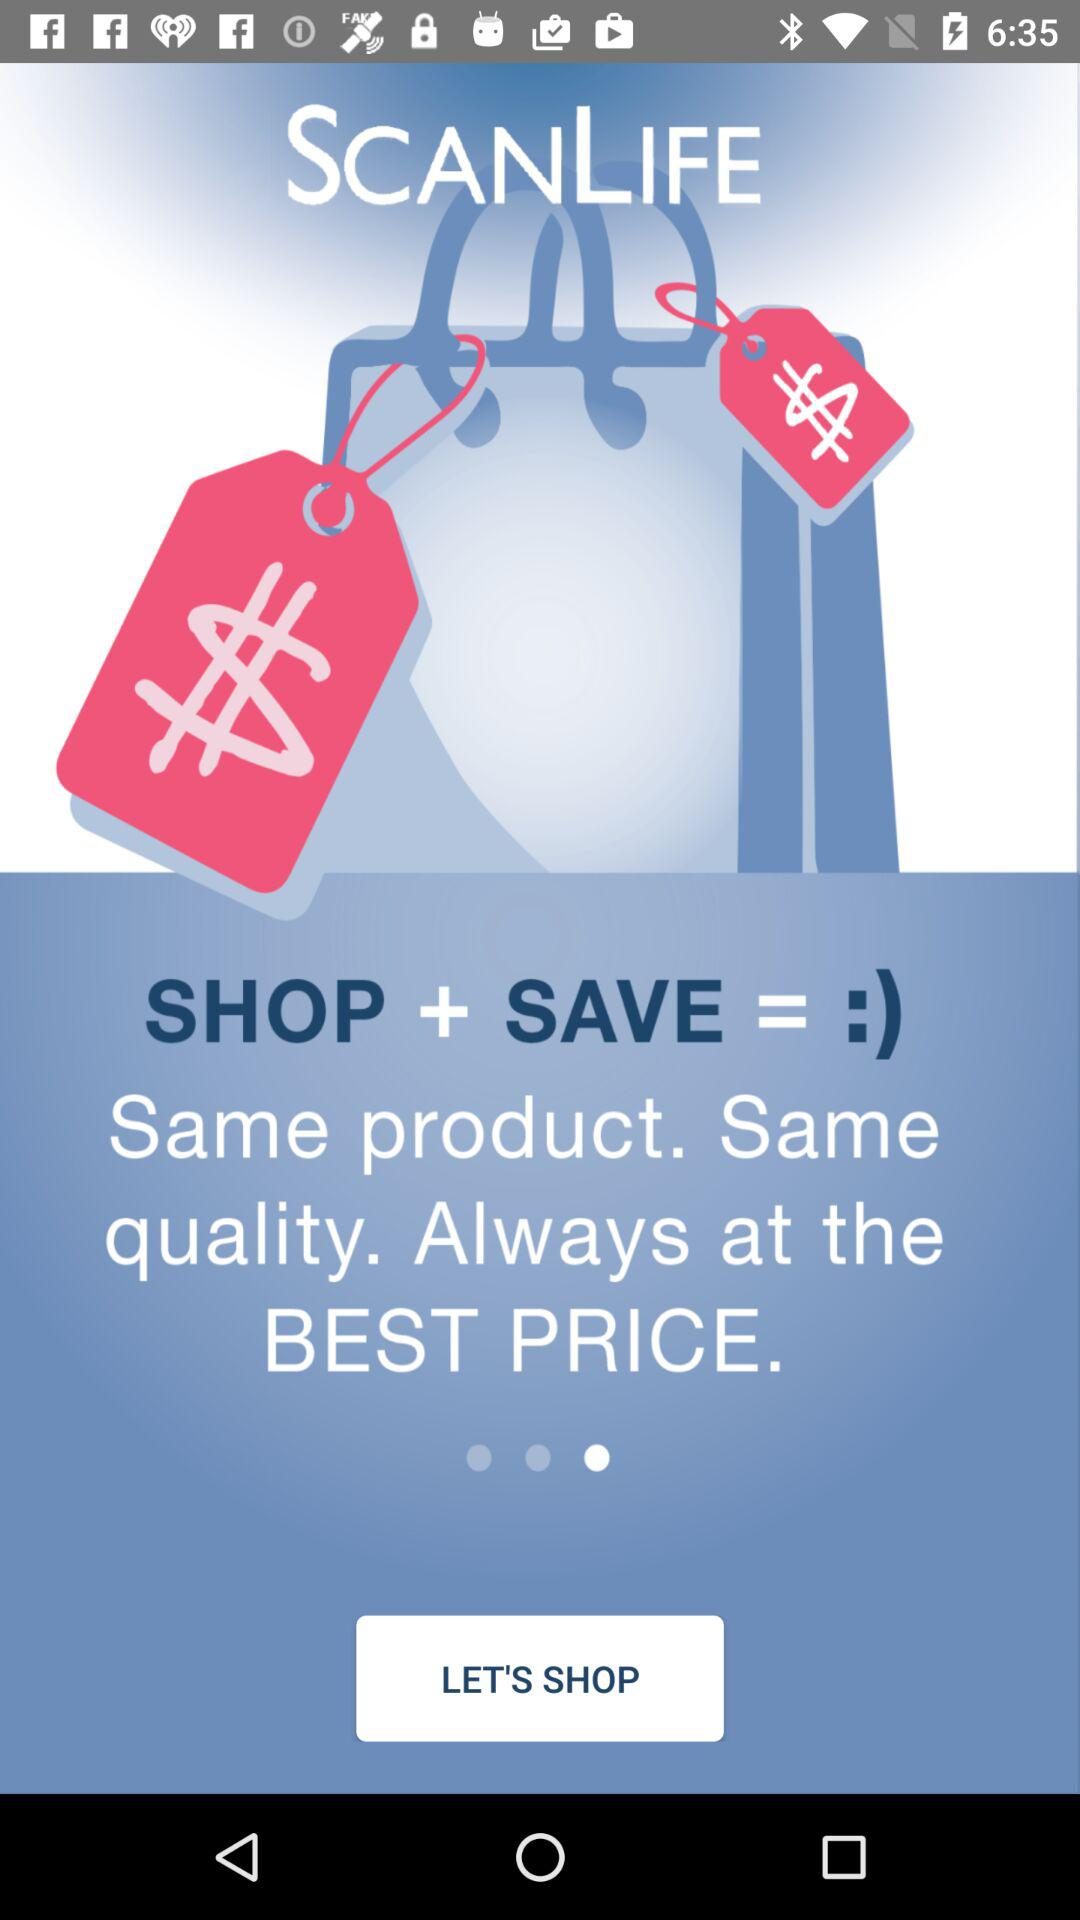What is the name of the application? The name of the application is "SCANLIFE". 